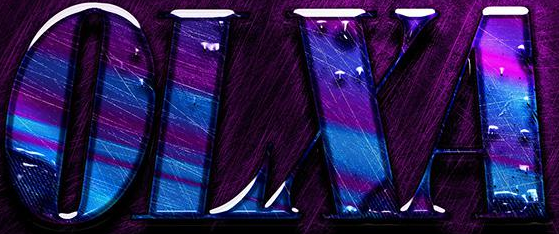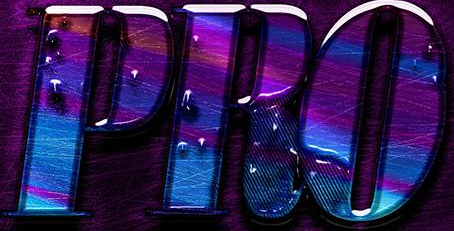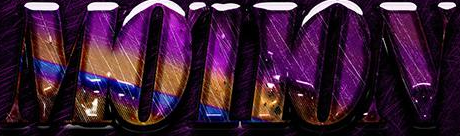Read the text content from these images in order, separated by a semicolon. OLXA; PRO; MOTION 